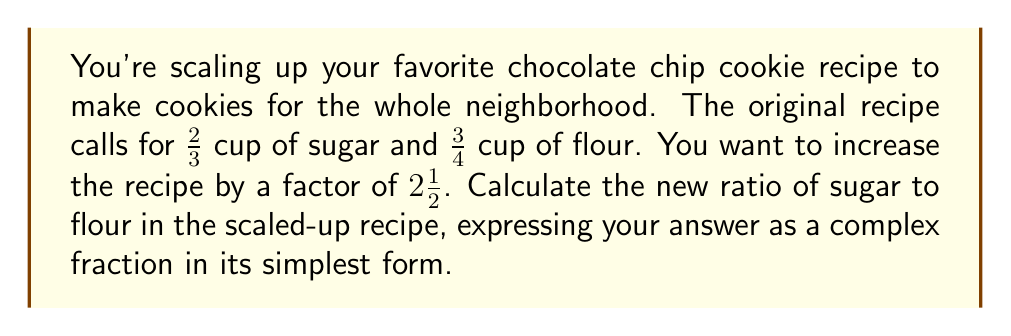What is the answer to this math problem? Let's approach this step-by-step:

1) First, let's scale up each ingredient:

   Sugar: $\frac{2}{3} \times 2\frac{1}{2} = \frac{2}{3} \times \frac{5}{2} = \frac{10}{6} = \frac{5}{3}$ cups
   Flour: $\frac{3}{4} \times 2\frac{1}{2} = \frac{3}{4} \times \frac{5}{2} = \frac{15}{8}$ cups

2) Now, we need to find the ratio of sugar to flour. This is done by dividing the amount of sugar by the amount of flour:

   $$\frac{\text{Sugar}}{\text{Flour}} = \frac{\frac{5}{3}}{\frac{15}{8}}$$

3) To divide fractions, we multiply by the reciprocal:

   $$\frac{\frac{5}{3}}{\frac{15}{8}} = \frac{5}{3} \times \frac{8}{15}$$

4) Multiply the numerators and denominators:

   $$\frac{5 \times 8}{3 \times 15} = \frac{40}{45}$$

5) Simplify by dividing both numerator and denominator by their greatest common divisor (5):

   $$\frac{40 \div 5}{45 \div 5} = \frac{8}{9}$$

Therefore, the new ratio of sugar to flour in the scaled-up recipe is $\frac{8}{9}$.
Answer: $\frac{8}{9}$ 